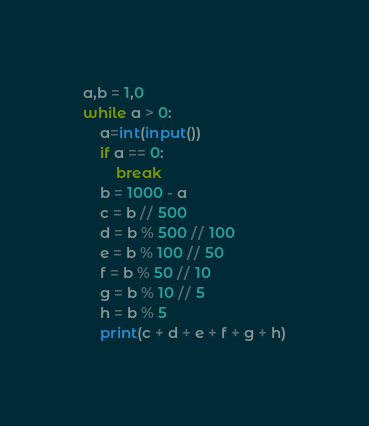Convert code to text. <code><loc_0><loc_0><loc_500><loc_500><_Python_>a,b = 1,0
while a > 0:
    a=int(input())
    if a == 0:
        break
    b = 1000 - a
    c = b // 500
    d = b % 500 // 100
    e = b % 100 // 50
    f = b % 50 // 10
    g = b % 10 // 5
    h = b % 5
    print(c + d + e + f + g + h)
</code> 